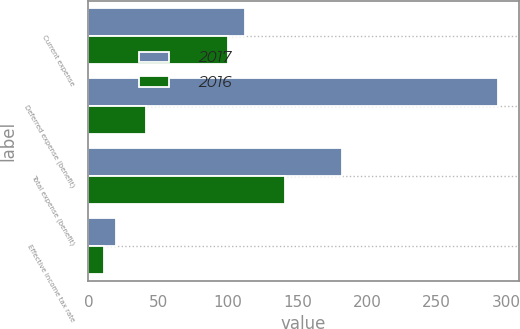<chart> <loc_0><loc_0><loc_500><loc_500><stacked_bar_chart><ecel><fcel>Current expense<fcel>Deferred expense (benefit)<fcel>Total expense (benefit)<fcel>Effective income tax rate<nl><fcel>2017<fcel>112<fcel>294<fcel>182<fcel>20<nl><fcel>2016<fcel>100<fcel>41<fcel>141<fcel>11<nl></chart> 